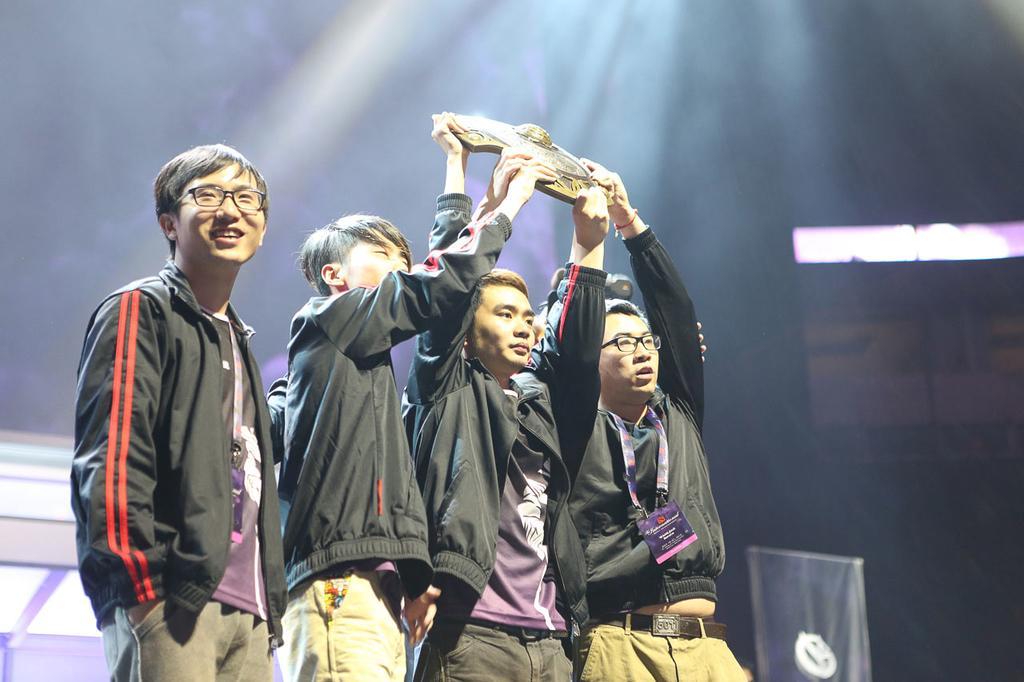How many people are in the image? There are four boys in the image. What are three of the boys holding in their hands? Three of the boys are holding a shield in their hands. Is there a woman in the image holding a pen and writing a story? No, there is no woman present in the image, and the boys are not holding pens or writing stories. 